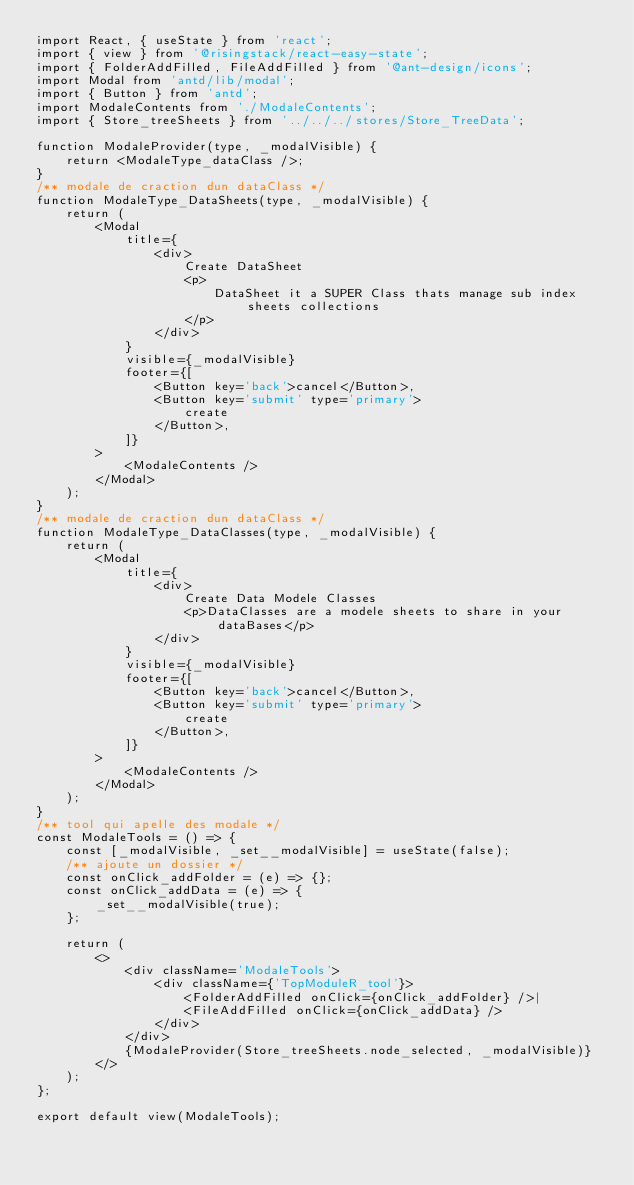Convert code to text. <code><loc_0><loc_0><loc_500><loc_500><_JavaScript_>import React, { useState } from 'react';
import { view } from '@risingstack/react-easy-state';
import { FolderAddFilled, FileAddFilled } from '@ant-design/icons';
import Modal from 'antd/lib/modal';
import { Button } from 'antd';
import ModaleContents from './ModaleContents';
import { Store_treeSheets } from '../../../stores/Store_TreeData';

function ModaleProvider(type, _modalVisible) {
	return <ModaleType_dataClass />;
}
/** modale de craction dun dataClass */
function ModaleType_DataSheets(type, _modalVisible) {
	return (
		<Modal
			title={
				<div>
					Create DataSheet
					<p>
						DataSheet it a SUPER Class thats manage sub index sheets collections
					</p>
				</div>
			}
			visible={_modalVisible}
			footer={[
				<Button key='back'>cancel</Button>,
				<Button key='submit' type='primary'>
					create
				</Button>,
			]}
		>
			<ModaleContents />
		</Modal>
	);
}
/** modale de craction dun dataClass */
function ModaleType_DataClasses(type, _modalVisible) {
	return (
		<Modal
			title={
				<div>
					Create Data Modele Classes
					<p>DataClasses are a modele sheets to share in your dataBases</p>
				</div>
			}
			visible={_modalVisible}
			footer={[
				<Button key='back'>cancel</Button>,
				<Button key='submit' type='primary'>
					create
				</Button>,
			]}
		>
			<ModaleContents />
		</Modal>
	);
}
/** tool qui apelle des modale */
const ModaleTools = () => {
	const [_modalVisible, _set__modalVisible] = useState(false);
	/** ajoute un dossier */
	const onClick_addFolder = (e) => {};
	const onClick_addData = (e) => {
		_set__modalVisible(true);
	};

	return (
		<>
			<div className='ModaleTools'>
				<div className={'TopModuleR_tool'}>
					<FolderAddFilled onClick={onClick_addFolder} />|
					<FileAddFilled onClick={onClick_addData} />
				</div>
			</div>
			{ModaleProvider(Store_treeSheets.node_selected, _modalVisible)}
		</>
	);
};

export default view(ModaleTools);
</code> 